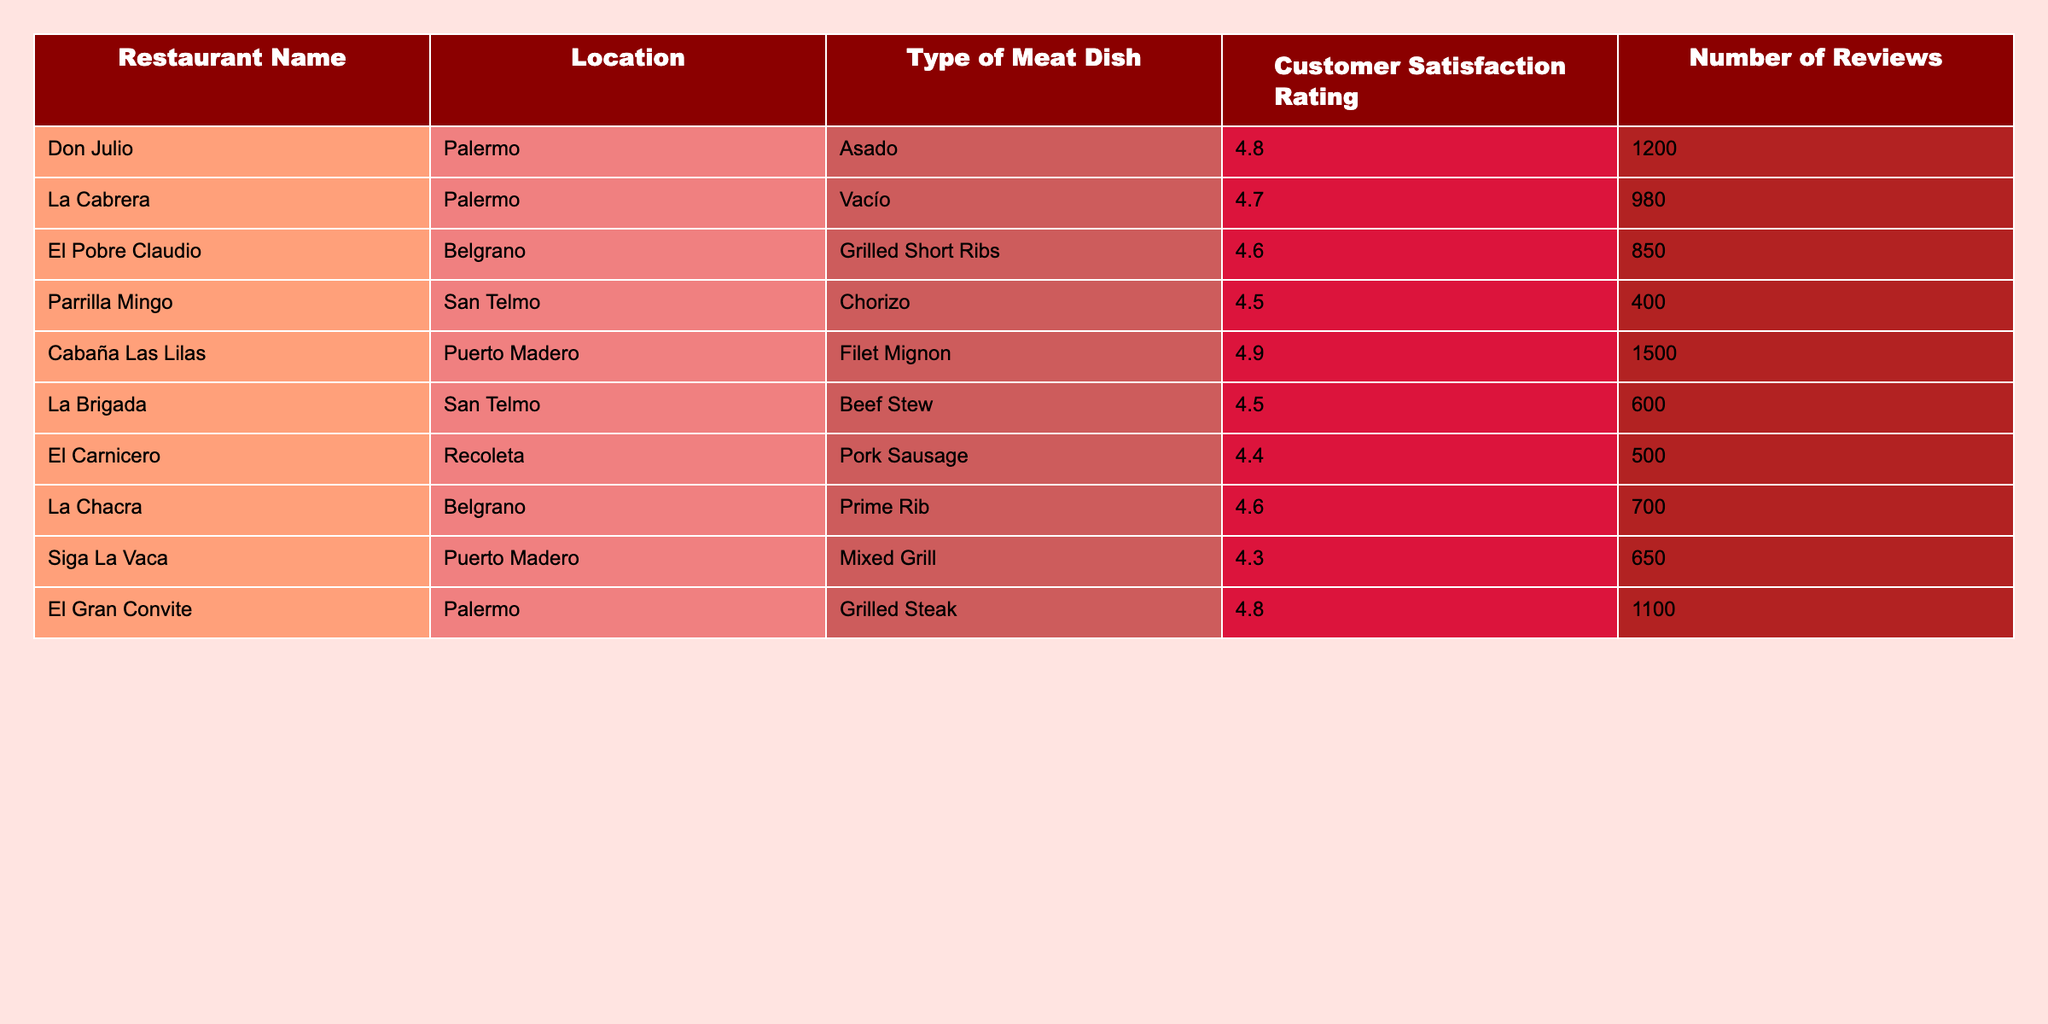What is the highest customer satisfaction rating for a meat-based dish in the table? The table shows various customer satisfaction ratings, among which the highest is 4.9 for the Filet Mignon at Cabaña Las Lilas.
Answer: 4.9 Which restaurant has the lowest customer satisfaction rating? By scanning through the ratings, El Carnicero has the lowest rating, which is 4.4.
Answer: 4.4 How many reviews did La Cabrera receive? The table explicitly states that La Cabrera received 980 reviews.
Answer: 980 What is the average customer satisfaction rating for the restaurants listed? To find the average, sum all ratings (4.8 + 4.7 + 4.6 + 4.5 + 4.9 + 4.5 + 4.4 + 4.6 + 4.3 + 4.8 = 46.7) and divide by the number of restaurants (10), which gives the average as 46.7 / 10 = 4.67.
Answer: 4.67 Is there any restaurant with a customer satisfaction rating below 4.5? Yes, El Carnicero (4.4) and Siga La Vaca (4.3) have ratings below 4.5.
Answer: Yes How many more reviews does Cabaña Las Lilas have compared to Parrilla Mingo? To find this difference, subtract the number of reviews for Parrilla Mingo (400) from Cabaña Las Lilas (1500), resulting in 1500 - 400 = 1100.
Answer: 1100 Which type of meat dish has the highest rating and how many reviews did it receive? The highest rating is 4.9 for the Filet Mignon at Cabaña Las Lilas, which received 1500 reviews.
Answer: Filet Mignon, 1500 reviews If you combine the reviews of Don Julio and El Gran Convite, how many reviews do you get? Adding the reviews from Don Julio (1200) and El Gran Convite (1100) gives a total of 1200 + 1100 = 2300 reviews.
Answer: 2300 Which location has the most restaurants listed in the table? Looking at the table, Palermo has 3 restaurants listed (Don Julio, El Gran Convite, and La Cabrera), while other locations have less.
Answer: Palermo What percentage of customers rated La Chacra with a satisfaction rating of 4.6 or higher? La Chacra's rating is 4.6 and out of 10 restaurants, 6 have ratings of 4.6 or higher. Therefore, (6/10) * 100 = 60%.
Answer: 60% 